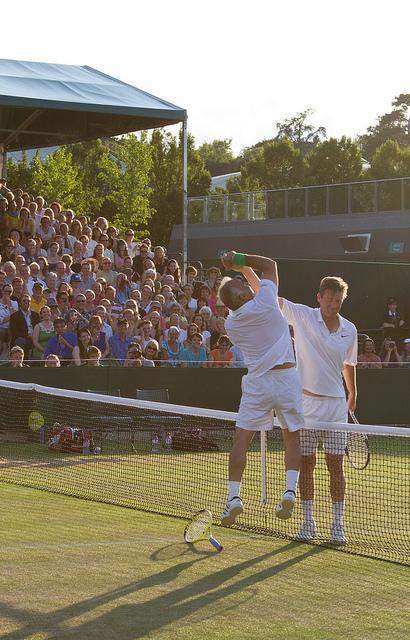What is the profession of the men in white?
Answer the question by selecting the correct answer among the 4 following choices.
Options: Athletes, nurses, doctors, teachers. Athletes. 